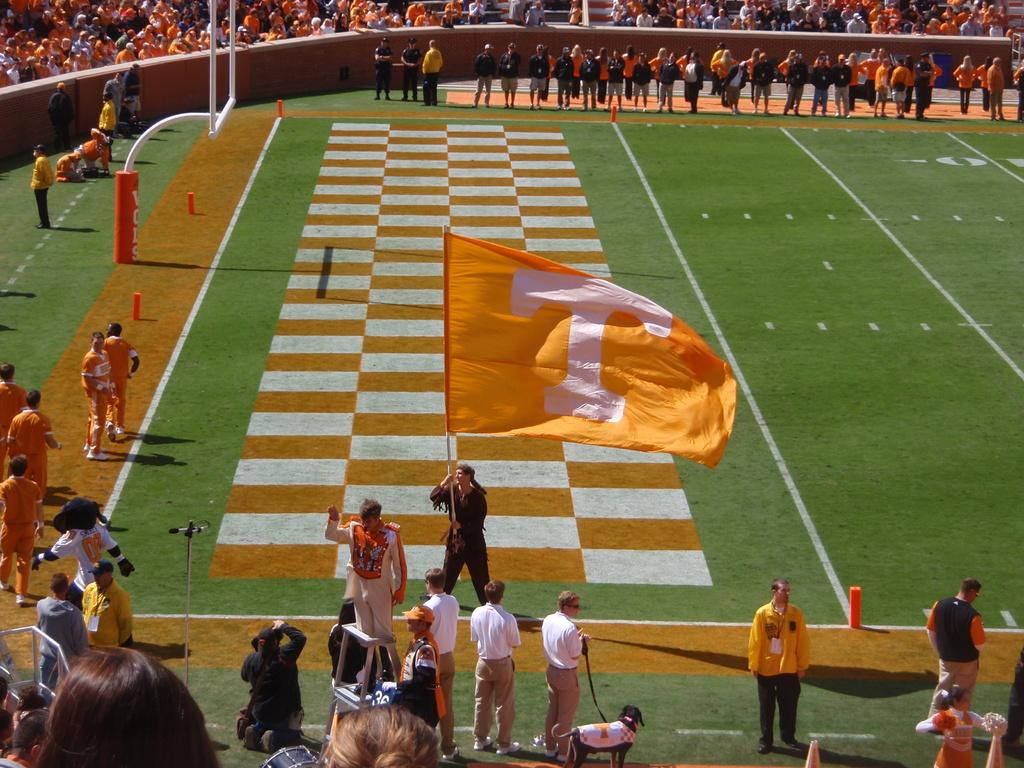What can be seen on the ground in the image? There are people on the ground in the image. What is the flag associated with in the image? The flag is in the image. What type of animal is present in the image? There is a dog in the image. What objects are visible in the image? There are objects in the image. What can be seen in the background of the image? There is a wall and a group of people in the background of the image. Are there any plants being used as bait in the image? There is no mention of plants or bait in the image; it features people, a flag, a dog, objects, a wall, and a group of people in the background. 